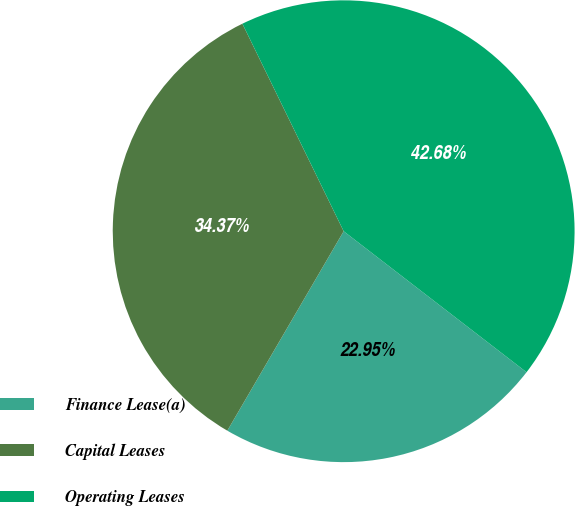<chart> <loc_0><loc_0><loc_500><loc_500><pie_chart><fcel>Finance Lease(a)<fcel>Capital Leases<fcel>Operating Leases<nl><fcel>22.95%<fcel>34.37%<fcel>42.68%<nl></chart> 